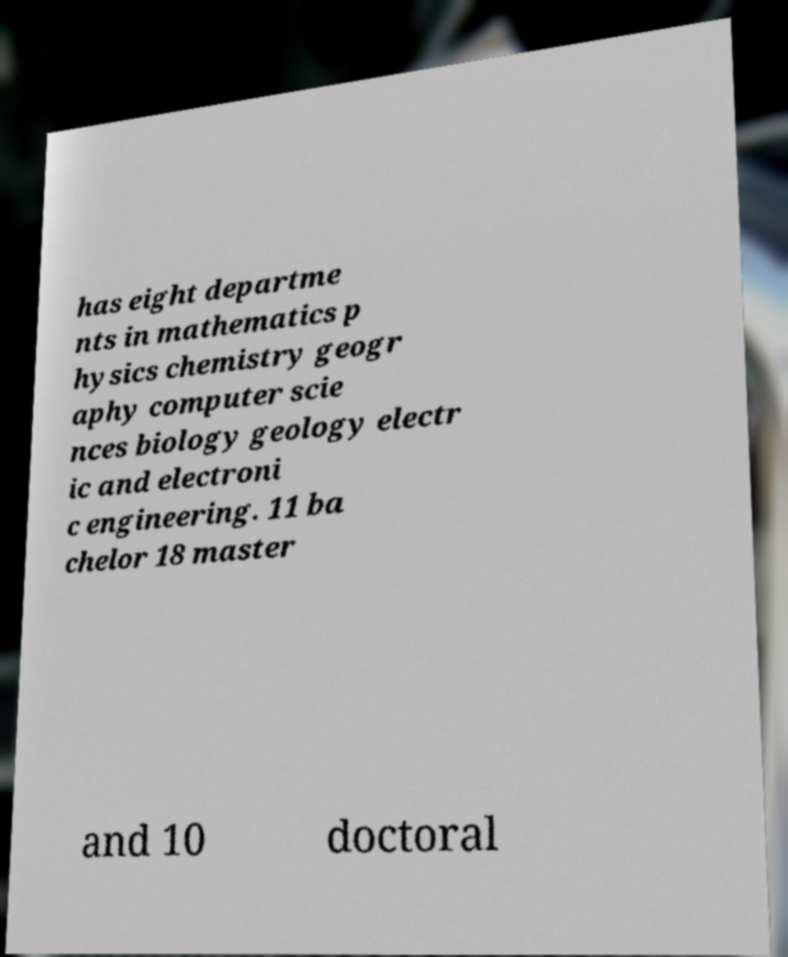Could you extract and type out the text from this image? has eight departme nts in mathematics p hysics chemistry geogr aphy computer scie nces biology geology electr ic and electroni c engineering. 11 ba chelor 18 master and 10 doctoral 